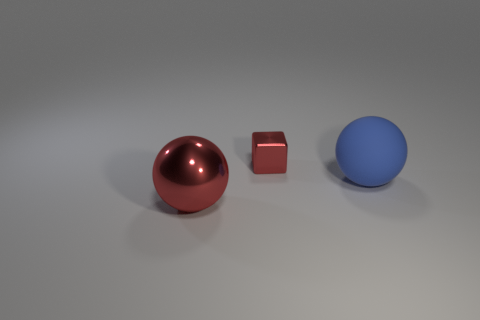Is there anything about the lighting in the scene that stands out? The lighting in the scene appears to be soft and diffused, casting gentle shadows beneath the objects and promoting a calm, neutral ambiance. There's a noticeable highlight on the top of the large red sphere, suggesting a light source positioned above. The light reveals the contours of the objects and enhances their three-dimensional appearance. 